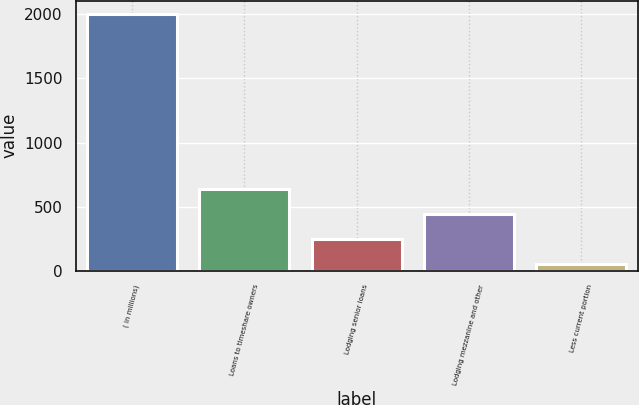Convert chart to OTSL. <chart><loc_0><loc_0><loc_500><loc_500><bar_chart><fcel>( in millions)<fcel>Loans to timeshare owners<fcel>Lodging senior loans<fcel>Lodging mezzanine and other<fcel>Less current portion<nl><fcel>2005<fcel>635.1<fcel>243.7<fcel>439.4<fcel>48<nl></chart> 